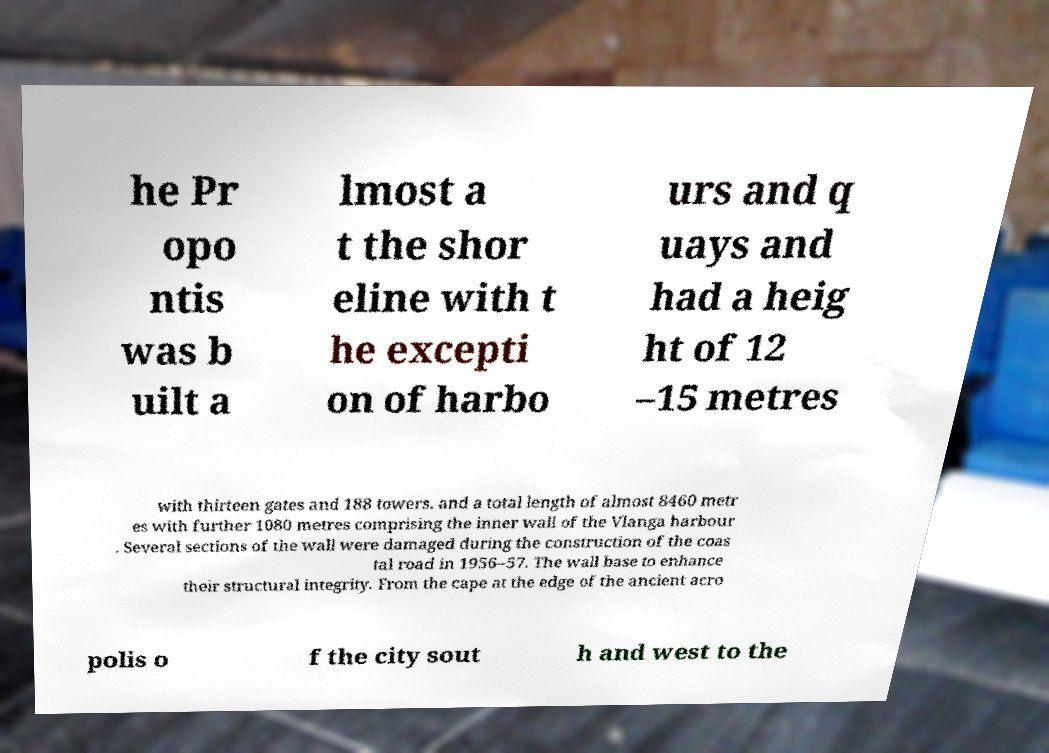I need the written content from this picture converted into text. Can you do that? he Pr opo ntis was b uilt a lmost a t the shor eline with t he excepti on of harbo urs and q uays and had a heig ht of 12 –15 metres with thirteen gates and 188 towers. and a total length of almost 8460 metr es with further 1080 metres comprising the inner wall of the Vlanga harbour . Several sections of the wall were damaged during the construction of the coas tal road in 1956–57. The wall base to enhance their structural integrity. From the cape at the edge of the ancient acro polis o f the city sout h and west to the 